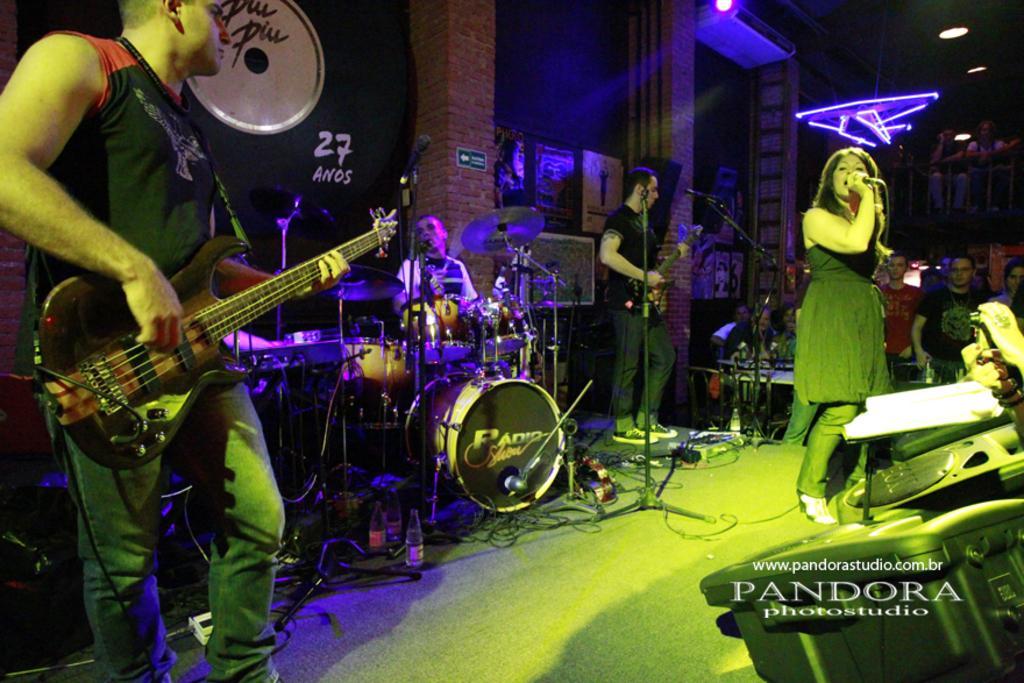Could you give a brief overview of what you see in this image? Here we can see a man is standing and playing the guitar, and at back here a person is playing the musical drums, and here a women is singing, and here a group of people are sitting. 